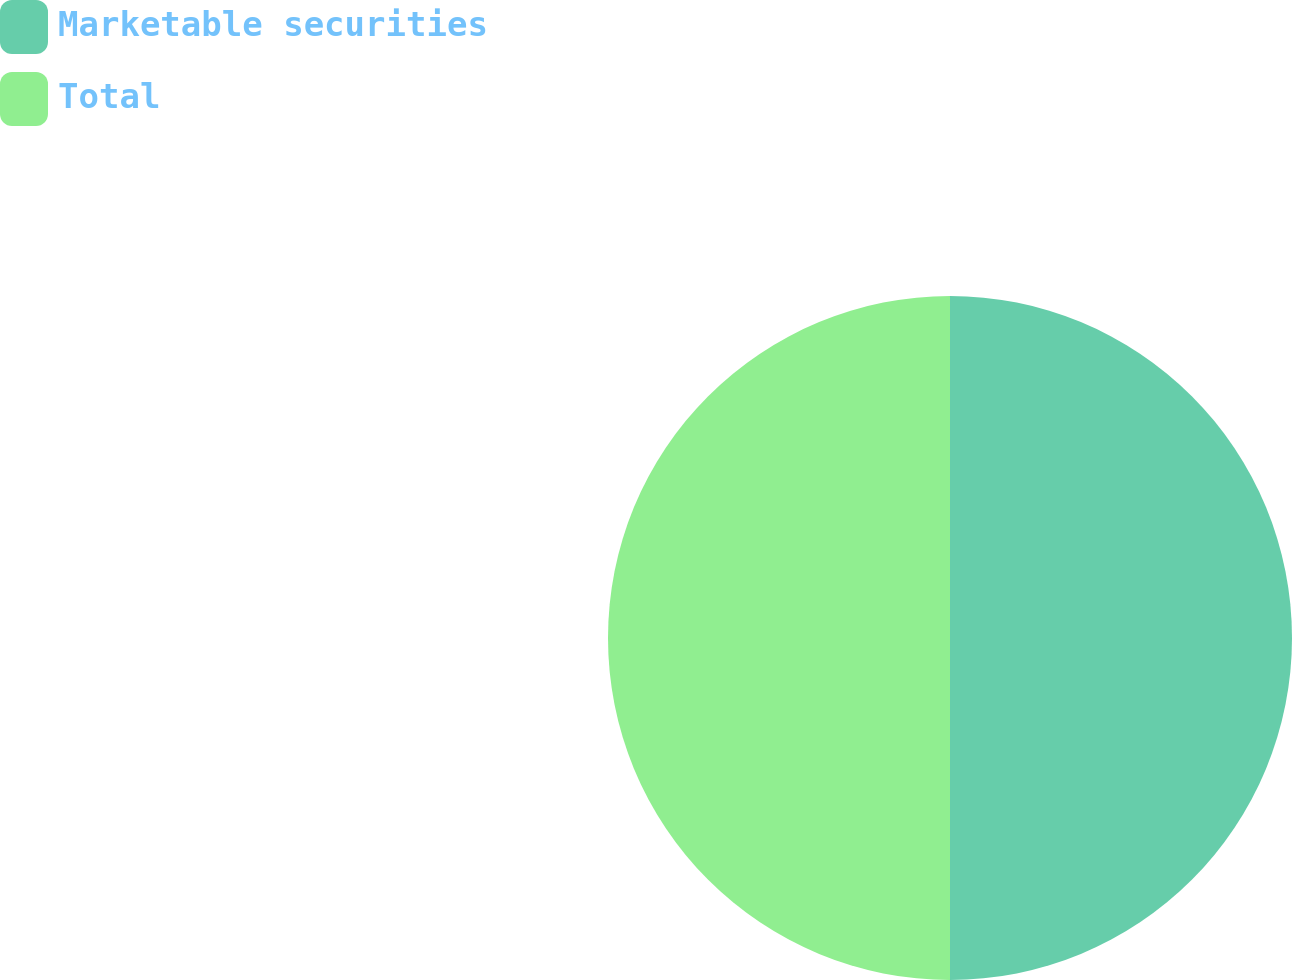Convert chart to OTSL. <chart><loc_0><loc_0><loc_500><loc_500><pie_chart><fcel>Marketable securities<fcel>Total<nl><fcel>50.0%<fcel>50.0%<nl></chart> 